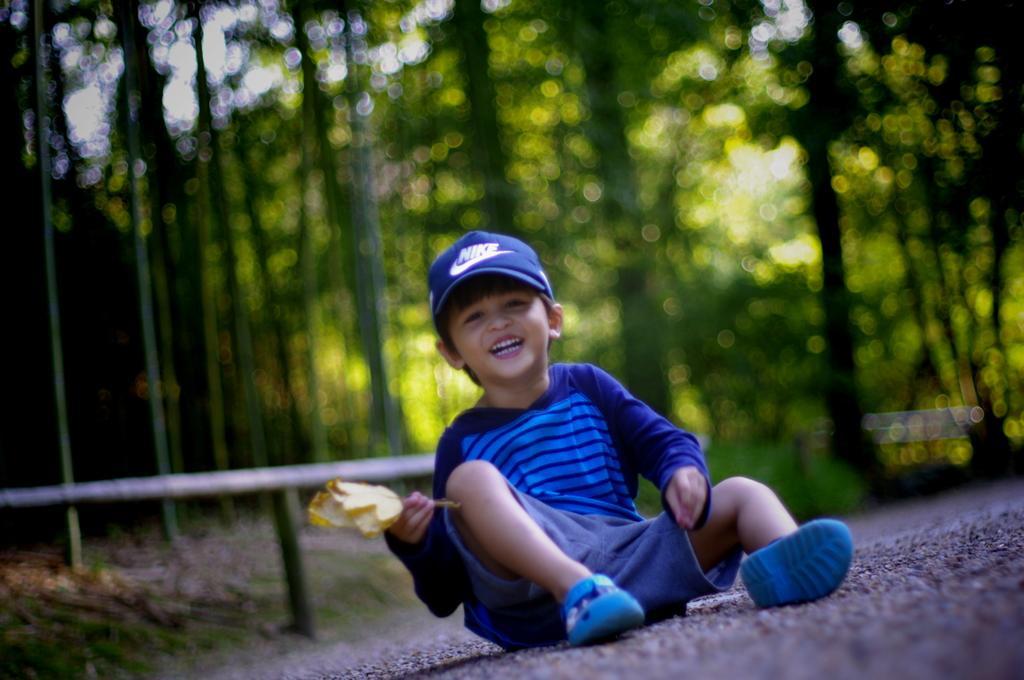Please provide a concise description of this image. In this image there is a boy sitting on the road by holding the flower. He is wearing the blue shirt and blue cap. In the background there are trees. 